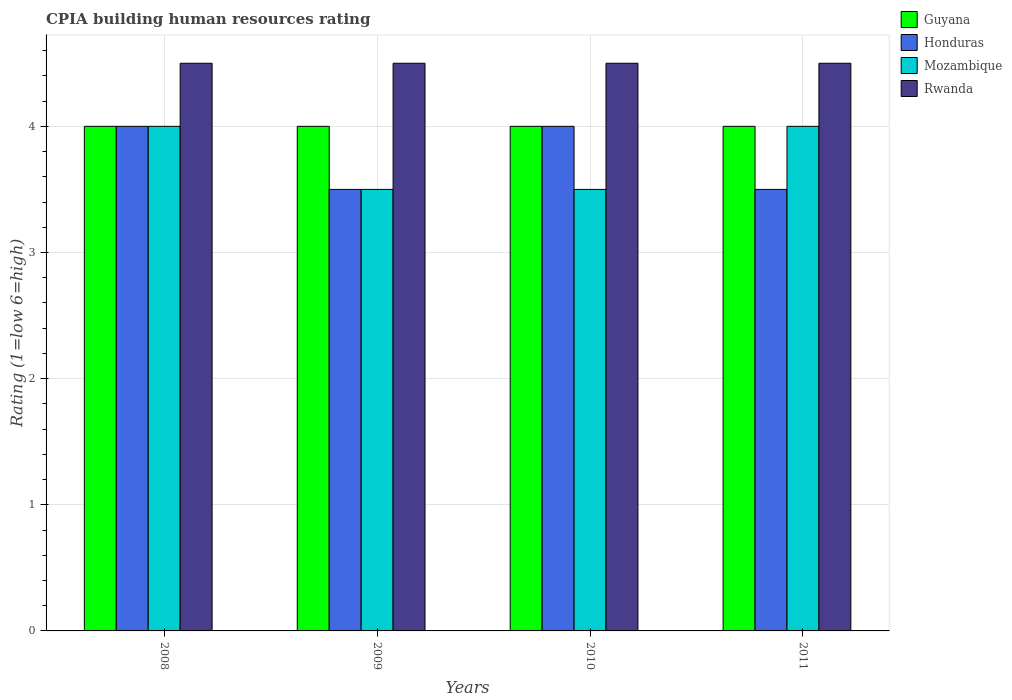How many different coloured bars are there?
Your response must be concise. 4. How many groups of bars are there?
Offer a terse response. 4. Are the number of bars per tick equal to the number of legend labels?
Offer a terse response. Yes. Are the number of bars on each tick of the X-axis equal?
Ensure brevity in your answer.  Yes. How many bars are there on the 1st tick from the left?
Your response must be concise. 4. What is the CPIA rating in Guyana in 2011?
Ensure brevity in your answer.  4. Across all years, what is the maximum CPIA rating in Mozambique?
Give a very brief answer. 4. Across all years, what is the minimum CPIA rating in Guyana?
Provide a succinct answer. 4. In which year was the CPIA rating in Guyana minimum?
Your answer should be very brief. 2008. What is the total CPIA rating in Guyana in the graph?
Make the answer very short. 16. What is the difference between the CPIA rating in Guyana in 2009 and that in 2010?
Give a very brief answer. 0. What is the average CPIA rating in Honduras per year?
Make the answer very short. 3.75. What is the ratio of the CPIA rating in Honduras in 2010 to that in 2011?
Offer a very short reply. 1.14. Is the CPIA rating in Guyana in 2008 less than that in 2010?
Give a very brief answer. No. Is the difference between the CPIA rating in Rwanda in 2009 and 2010 greater than the difference between the CPIA rating in Mozambique in 2009 and 2010?
Keep it short and to the point. No. What is the difference between the highest and the second highest CPIA rating in Mozambique?
Ensure brevity in your answer.  0. What is the difference between the highest and the lowest CPIA rating in Guyana?
Your answer should be very brief. 0. Is it the case that in every year, the sum of the CPIA rating in Rwanda and CPIA rating in Mozambique is greater than the sum of CPIA rating in Guyana and CPIA rating in Honduras?
Ensure brevity in your answer.  Yes. What does the 4th bar from the left in 2011 represents?
Your answer should be very brief. Rwanda. What does the 4th bar from the right in 2008 represents?
Provide a succinct answer. Guyana. How many years are there in the graph?
Give a very brief answer. 4. What is the difference between two consecutive major ticks on the Y-axis?
Provide a succinct answer. 1. Are the values on the major ticks of Y-axis written in scientific E-notation?
Give a very brief answer. No. Does the graph contain any zero values?
Your response must be concise. No. Does the graph contain grids?
Give a very brief answer. Yes. How are the legend labels stacked?
Offer a very short reply. Vertical. What is the title of the graph?
Your answer should be very brief. CPIA building human resources rating. Does "Mauritius" appear as one of the legend labels in the graph?
Your answer should be very brief. No. What is the Rating (1=low 6=high) in Honduras in 2008?
Keep it short and to the point. 4. What is the Rating (1=low 6=high) of Honduras in 2009?
Your response must be concise. 3.5. What is the Rating (1=low 6=high) in Mozambique in 2009?
Keep it short and to the point. 3.5. What is the Rating (1=low 6=high) in Rwanda in 2009?
Provide a short and direct response. 4.5. What is the Rating (1=low 6=high) in Honduras in 2010?
Provide a short and direct response. 4. What is the Rating (1=low 6=high) of Mozambique in 2010?
Your answer should be compact. 3.5. What is the Rating (1=low 6=high) of Guyana in 2011?
Your response must be concise. 4. What is the Rating (1=low 6=high) in Mozambique in 2011?
Provide a short and direct response. 4. What is the Rating (1=low 6=high) of Rwanda in 2011?
Offer a terse response. 4.5. Across all years, what is the maximum Rating (1=low 6=high) in Honduras?
Give a very brief answer. 4. Across all years, what is the maximum Rating (1=low 6=high) of Mozambique?
Provide a short and direct response. 4. Across all years, what is the maximum Rating (1=low 6=high) of Rwanda?
Your answer should be compact. 4.5. Across all years, what is the minimum Rating (1=low 6=high) in Honduras?
Your answer should be compact. 3.5. Across all years, what is the minimum Rating (1=low 6=high) of Rwanda?
Your answer should be very brief. 4.5. What is the total Rating (1=low 6=high) of Honduras in the graph?
Your answer should be compact. 15. What is the total Rating (1=low 6=high) of Mozambique in the graph?
Offer a terse response. 15. What is the difference between the Rating (1=low 6=high) of Honduras in 2008 and that in 2009?
Give a very brief answer. 0.5. What is the difference between the Rating (1=low 6=high) in Rwanda in 2008 and that in 2009?
Ensure brevity in your answer.  0. What is the difference between the Rating (1=low 6=high) of Rwanda in 2008 and that in 2010?
Provide a short and direct response. 0. What is the difference between the Rating (1=low 6=high) in Guyana in 2008 and that in 2011?
Provide a succinct answer. 0. What is the difference between the Rating (1=low 6=high) in Honduras in 2008 and that in 2011?
Offer a very short reply. 0.5. What is the difference between the Rating (1=low 6=high) of Mozambique in 2008 and that in 2011?
Make the answer very short. 0. What is the difference between the Rating (1=low 6=high) of Rwanda in 2009 and that in 2010?
Offer a very short reply. 0. What is the difference between the Rating (1=low 6=high) of Guyana in 2009 and that in 2011?
Your answer should be compact. 0. What is the difference between the Rating (1=low 6=high) of Mozambique in 2009 and that in 2011?
Your answer should be compact. -0.5. What is the difference between the Rating (1=low 6=high) of Honduras in 2010 and that in 2011?
Offer a terse response. 0.5. What is the difference between the Rating (1=low 6=high) of Mozambique in 2010 and that in 2011?
Your response must be concise. -0.5. What is the difference between the Rating (1=low 6=high) in Guyana in 2008 and the Rating (1=low 6=high) in Honduras in 2009?
Offer a very short reply. 0.5. What is the difference between the Rating (1=low 6=high) in Honduras in 2008 and the Rating (1=low 6=high) in Rwanda in 2009?
Keep it short and to the point. -0.5. What is the difference between the Rating (1=low 6=high) in Mozambique in 2008 and the Rating (1=low 6=high) in Rwanda in 2009?
Offer a terse response. -0.5. What is the difference between the Rating (1=low 6=high) of Guyana in 2008 and the Rating (1=low 6=high) of Mozambique in 2010?
Your answer should be very brief. 0.5. What is the difference between the Rating (1=low 6=high) of Honduras in 2008 and the Rating (1=low 6=high) of Mozambique in 2010?
Provide a succinct answer. 0.5. What is the difference between the Rating (1=low 6=high) of Honduras in 2008 and the Rating (1=low 6=high) of Rwanda in 2010?
Keep it short and to the point. -0.5. What is the difference between the Rating (1=low 6=high) of Mozambique in 2008 and the Rating (1=low 6=high) of Rwanda in 2010?
Your answer should be compact. -0.5. What is the difference between the Rating (1=low 6=high) of Guyana in 2008 and the Rating (1=low 6=high) of Rwanda in 2011?
Ensure brevity in your answer.  -0.5. What is the difference between the Rating (1=low 6=high) of Honduras in 2008 and the Rating (1=low 6=high) of Mozambique in 2011?
Make the answer very short. 0. What is the difference between the Rating (1=low 6=high) of Guyana in 2009 and the Rating (1=low 6=high) of Honduras in 2010?
Your answer should be compact. 0. What is the difference between the Rating (1=low 6=high) of Honduras in 2009 and the Rating (1=low 6=high) of Mozambique in 2010?
Offer a terse response. 0. What is the difference between the Rating (1=low 6=high) of Guyana in 2009 and the Rating (1=low 6=high) of Mozambique in 2011?
Offer a terse response. 0. What is the difference between the Rating (1=low 6=high) in Guyana in 2009 and the Rating (1=low 6=high) in Rwanda in 2011?
Make the answer very short. -0.5. What is the difference between the Rating (1=low 6=high) of Honduras in 2009 and the Rating (1=low 6=high) of Mozambique in 2011?
Your response must be concise. -0.5. What is the difference between the Rating (1=low 6=high) in Honduras in 2009 and the Rating (1=low 6=high) in Rwanda in 2011?
Give a very brief answer. -1. What is the difference between the Rating (1=low 6=high) of Mozambique in 2009 and the Rating (1=low 6=high) of Rwanda in 2011?
Keep it short and to the point. -1. What is the difference between the Rating (1=low 6=high) in Guyana in 2010 and the Rating (1=low 6=high) in Honduras in 2011?
Keep it short and to the point. 0.5. What is the difference between the Rating (1=low 6=high) of Guyana in 2010 and the Rating (1=low 6=high) of Mozambique in 2011?
Provide a succinct answer. 0. What is the difference between the Rating (1=low 6=high) of Honduras in 2010 and the Rating (1=low 6=high) of Mozambique in 2011?
Ensure brevity in your answer.  0. What is the average Rating (1=low 6=high) of Guyana per year?
Make the answer very short. 4. What is the average Rating (1=low 6=high) of Honduras per year?
Your response must be concise. 3.75. What is the average Rating (1=low 6=high) in Mozambique per year?
Provide a short and direct response. 3.75. What is the average Rating (1=low 6=high) in Rwanda per year?
Offer a very short reply. 4.5. In the year 2008, what is the difference between the Rating (1=low 6=high) of Guyana and Rating (1=low 6=high) of Honduras?
Your response must be concise. 0. In the year 2008, what is the difference between the Rating (1=low 6=high) of Guyana and Rating (1=low 6=high) of Rwanda?
Offer a very short reply. -0.5. In the year 2008, what is the difference between the Rating (1=low 6=high) in Honduras and Rating (1=low 6=high) in Mozambique?
Your answer should be very brief. 0. In the year 2008, what is the difference between the Rating (1=low 6=high) in Honduras and Rating (1=low 6=high) in Rwanda?
Keep it short and to the point. -0.5. In the year 2009, what is the difference between the Rating (1=low 6=high) in Guyana and Rating (1=low 6=high) in Mozambique?
Offer a terse response. 0.5. In the year 2009, what is the difference between the Rating (1=low 6=high) in Honduras and Rating (1=low 6=high) in Mozambique?
Offer a terse response. 0. In the year 2009, what is the difference between the Rating (1=low 6=high) of Mozambique and Rating (1=low 6=high) of Rwanda?
Your answer should be very brief. -1. In the year 2010, what is the difference between the Rating (1=low 6=high) of Honduras and Rating (1=low 6=high) of Rwanda?
Give a very brief answer. -0.5. In the year 2010, what is the difference between the Rating (1=low 6=high) of Mozambique and Rating (1=low 6=high) of Rwanda?
Offer a terse response. -1. In the year 2011, what is the difference between the Rating (1=low 6=high) of Mozambique and Rating (1=low 6=high) of Rwanda?
Offer a very short reply. -0.5. What is the ratio of the Rating (1=low 6=high) of Guyana in 2008 to that in 2009?
Provide a succinct answer. 1. What is the ratio of the Rating (1=low 6=high) of Mozambique in 2008 to that in 2009?
Offer a very short reply. 1.14. What is the ratio of the Rating (1=low 6=high) in Guyana in 2008 to that in 2010?
Keep it short and to the point. 1. What is the ratio of the Rating (1=low 6=high) of Mozambique in 2008 to that in 2010?
Your answer should be very brief. 1.14. What is the ratio of the Rating (1=low 6=high) in Rwanda in 2008 to that in 2010?
Offer a terse response. 1. What is the ratio of the Rating (1=low 6=high) in Honduras in 2008 to that in 2011?
Keep it short and to the point. 1.14. What is the ratio of the Rating (1=low 6=high) in Honduras in 2009 to that in 2010?
Provide a short and direct response. 0.88. What is the ratio of the Rating (1=low 6=high) in Honduras in 2009 to that in 2011?
Provide a short and direct response. 1. What is the ratio of the Rating (1=low 6=high) in Guyana in 2010 to that in 2011?
Provide a succinct answer. 1. What is the ratio of the Rating (1=low 6=high) in Mozambique in 2010 to that in 2011?
Offer a very short reply. 0.88. What is the difference between the highest and the second highest Rating (1=low 6=high) in Mozambique?
Your answer should be compact. 0. What is the difference between the highest and the second highest Rating (1=low 6=high) in Rwanda?
Keep it short and to the point. 0. What is the difference between the highest and the lowest Rating (1=low 6=high) in Honduras?
Keep it short and to the point. 0.5. 